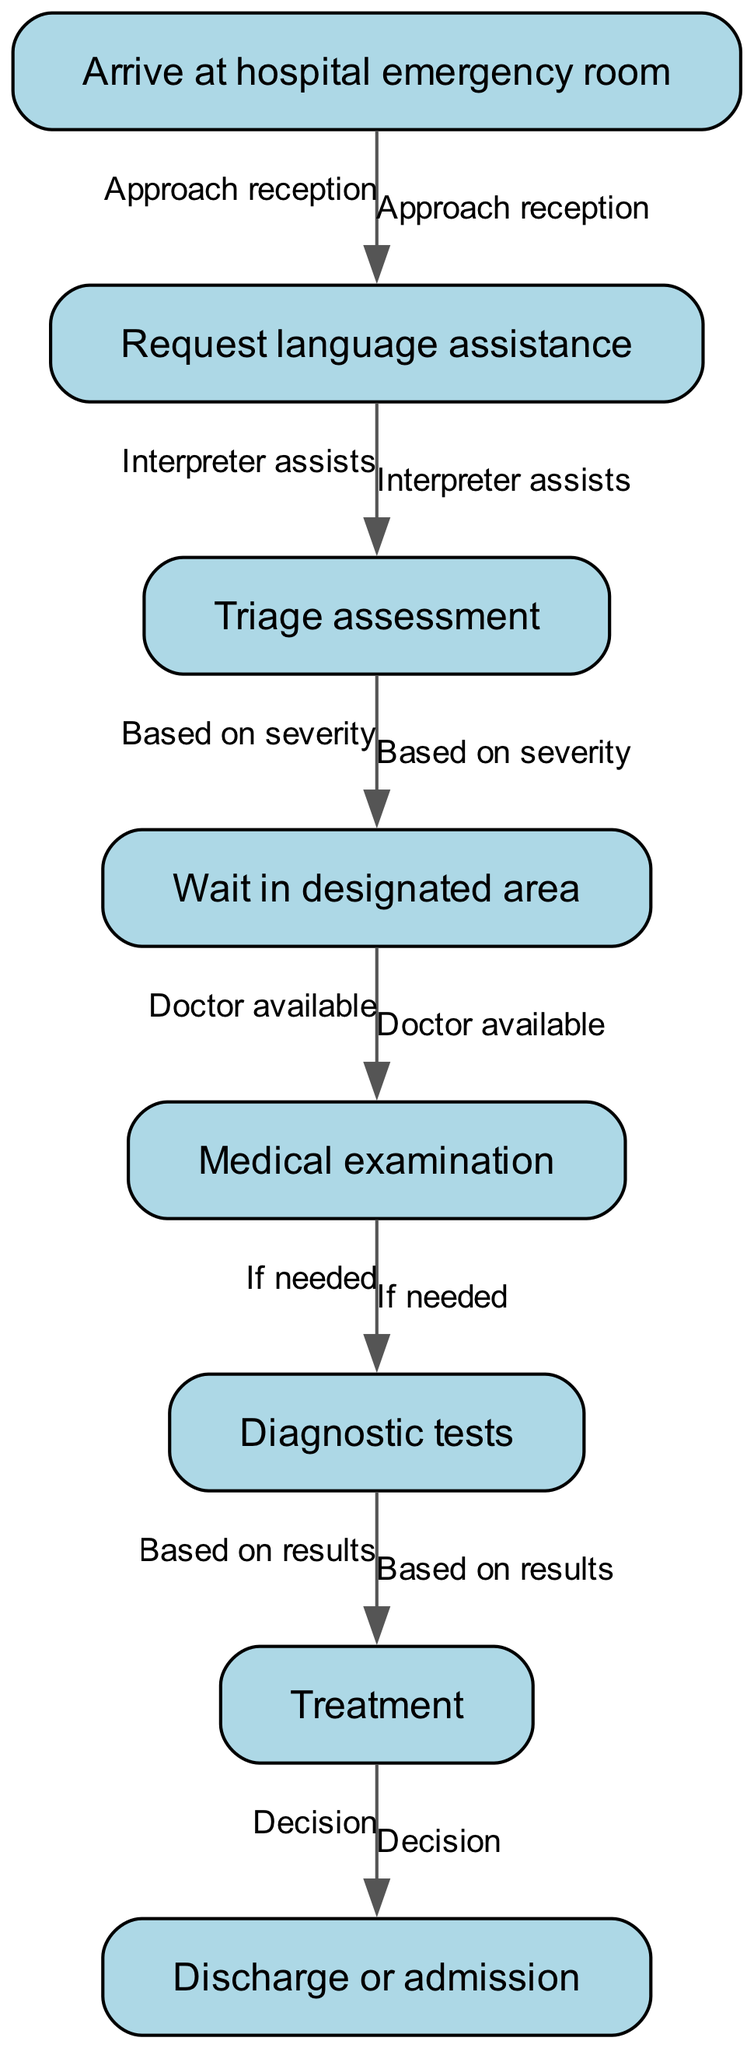What is the first step upon arrival at the hospital? The first step upon arrival at the hospital is to "Arrive at hospital emergency room." This is identified as the starting point in the flow chart, where all other processes stem from this action.
Answer: Arrive at hospital emergency room How many nodes are in the diagram? The diagram contains a total of eight nodes. By counting each unique step or action taken in the emergency room process, we determine that there are eight distinct actions represented in the diagram.
Answer: 8 What action follows the triage assessment? The action that follows the triage assessment is "Wait in designated area." This is indicated directly in the flow chart, as the edge from "Triage assessment" points to "Wait in designated area."
Answer: Wait in designated area What happens after the medical examination if needed? After the medical examination, if needed, "Diagnostic tests" occur. The flow chart specifies that the next step is determined based on the need established during the medical examination.
Answer: Diagnostic tests What leads to treatment? Treatment is reached based on the results of the diagnostic tests. The flow chart indicates that after completing diagnostic tests, the decision to move forward with treatment is dependent on the outcomes of those tests.
Answer: Based on results What is approached first to request language assistance? To request language assistance, one must "Approach reception" first. This is the necessary action indicated in the flow chart, linking it to the subsequent steps for obtaining assistance.
Answer: Approach reception What action is taken if the doctor is available? If the doctor is available, the action taken next is to "Medical examination." This step is clearly outlined in the flow chart, showing the progression from waiting to being examined when a doctor is available.
Answer: Medical examination What decision follows treatment? The decision that follows treatment is either "Discharge or admission." This indicates the final stage after treatment where the patient is either released or admitted for further care.
Answer: Discharge or admission 